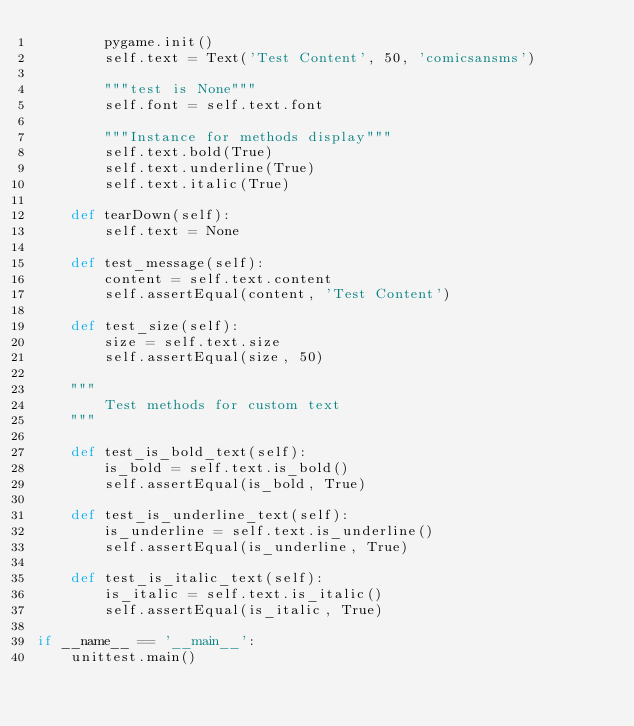Convert code to text. <code><loc_0><loc_0><loc_500><loc_500><_Python_>        pygame.init()
        self.text = Text('Test Content', 50, 'comicsansms')

        """test is None"""
        self.font = self.text.font

        """Instance for methods display"""
        self.text.bold(True)
        self.text.underline(True)
        self.text.italic(True)

    def tearDown(self):
        self.text = None

    def test_message(self):
        content = self.text.content
        self.assertEqual(content, 'Test Content')

    def test_size(self):
        size = self.text.size
        self.assertEqual(size, 50)

    """
        Test methods for custom text
    """

    def test_is_bold_text(self):
        is_bold = self.text.is_bold()
        self.assertEqual(is_bold, True)

    def test_is_underline_text(self):
        is_underline = self.text.is_underline()
        self.assertEqual(is_underline, True)

    def test_is_italic_text(self):
        is_italic = self.text.is_italic()
        self.assertEqual(is_italic, True)

if __name__ == '__main__':
    unittest.main()
</code> 